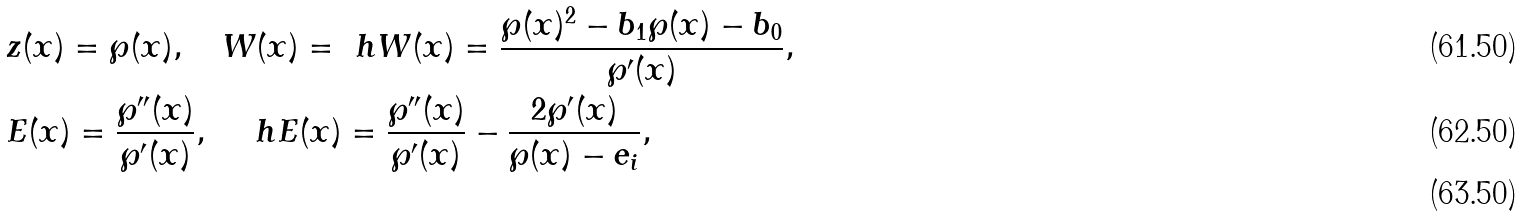<formula> <loc_0><loc_0><loc_500><loc_500>& z ( x ) = \wp ( x ) , \quad W ( x ) = \ h W ( x ) = \frac { \wp ( x ) ^ { 2 } - b _ { 1 } \wp ( x ) - b _ { 0 } } { \wp ^ { \prime } ( x ) } , \\ & E ( x ) = \frac { \wp ^ { \prime \prime } ( x ) } { \wp ^ { \prime } ( x ) } , \quad \ h E ( x ) = \frac { \wp ^ { \prime \prime } ( x ) } { \wp ^ { \prime } ( x ) } - \frac { 2 \wp ^ { \prime } ( x ) } { \wp ( x ) - e _ { i } } , \\</formula> 